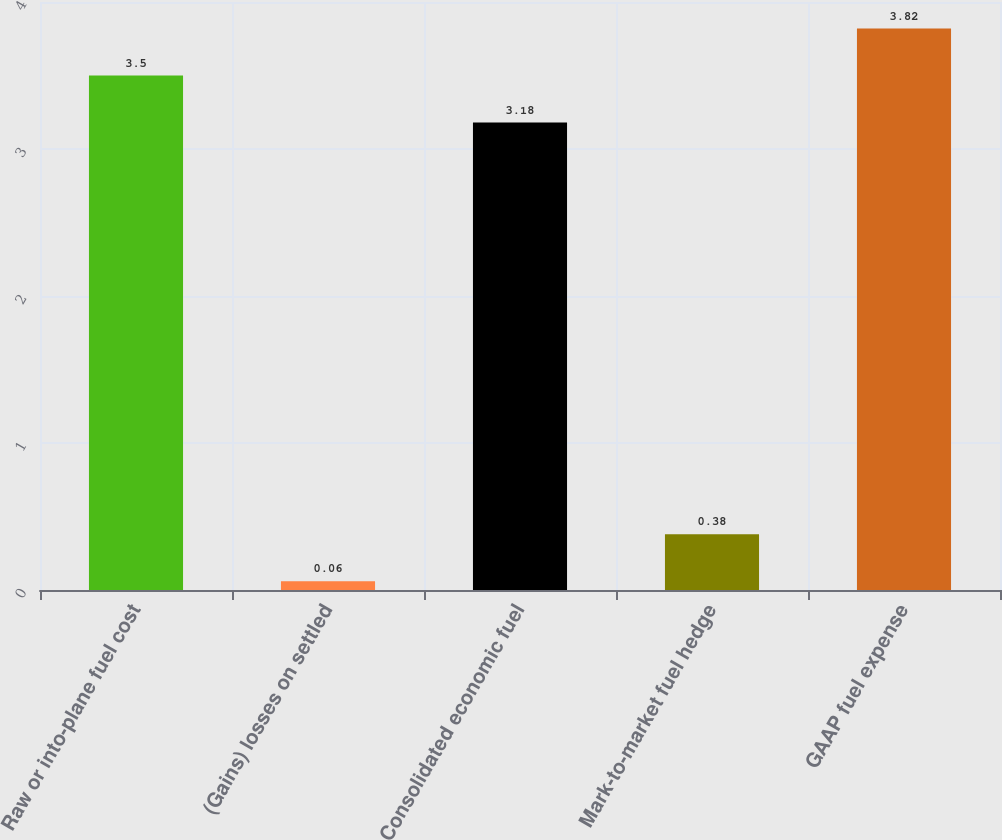Convert chart to OTSL. <chart><loc_0><loc_0><loc_500><loc_500><bar_chart><fcel>Raw or into-plane fuel cost<fcel>(Gains) losses on settled<fcel>Consolidated economic fuel<fcel>Mark-to-market fuel hedge<fcel>GAAP fuel expense<nl><fcel>3.5<fcel>0.06<fcel>3.18<fcel>0.38<fcel>3.82<nl></chart> 